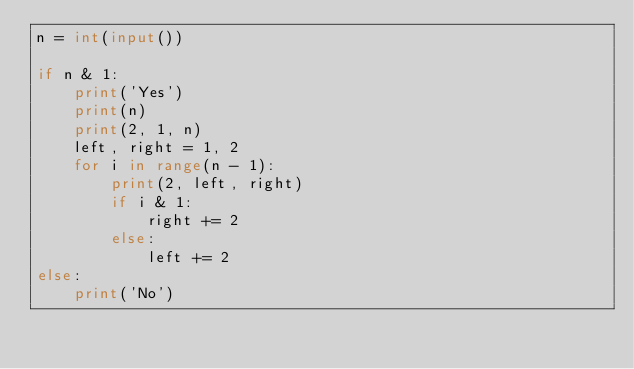Convert code to text. <code><loc_0><loc_0><loc_500><loc_500><_Python_>n = int(input())

if n & 1:
    print('Yes')
    print(n)
    print(2, 1, n)
    left, right = 1, 2
    for i in range(n - 1):
        print(2, left, right)
        if i & 1:
            right += 2
        else:
            left += 2
else:
    print('No')
</code> 